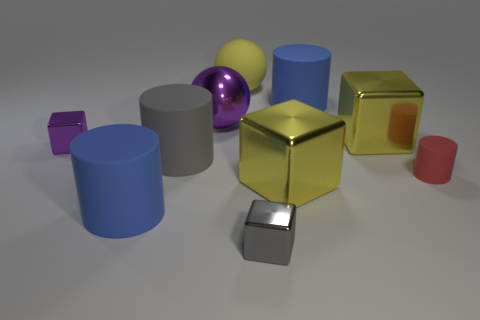Subtract all cylinders. How many objects are left? 6 Subtract all purple balls. How many balls are left? 1 Subtract all gray cylinders. How many cylinders are left? 3 Subtract 2 cubes. How many cubes are left? 2 Add 8 small gray cubes. How many small gray cubes exist? 9 Subtract 0 brown blocks. How many objects are left? 10 Subtract all yellow cylinders. Subtract all gray balls. How many cylinders are left? 4 Subtract all gray cylinders. How many brown cubes are left? 0 Subtract all red matte spheres. Subtract all gray cylinders. How many objects are left? 9 Add 6 tiny purple metal blocks. How many tiny purple metal blocks are left? 7 